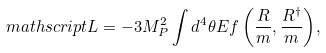Convert formula to latex. <formula><loc_0><loc_0><loc_500><loc_500>\ m a t h s c r i p t { L } = - 3 M _ { P } ^ { 2 } \int { d ^ { 4 } \theta E f \left ( \frac { R } { m } , \frac { R ^ { \dag } } { m } \right ) } ,</formula> 